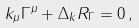Convert formula to latex. <formula><loc_0><loc_0><loc_500><loc_500>k _ { \mu } \Gamma ^ { \mu } + \Delta _ { k } R _ { \Gamma } = 0 \, ,</formula> 